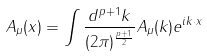Convert formula to latex. <formula><loc_0><loc_0><loc_500><loc_500>A _ { \mu } ( x ) = \int \frac { d ^ { p + 1 } k } { ( 2 \pi ) ^ { \frac { p + 1 } { 2 } } } A _ { \mu } ( k ) e ^ { i k \cdot { x } }</formula> 